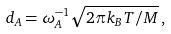<formula> <loc_0><loc_0><loc_500><loc_500>d _ { A } = \omega _ { A } ^ { - 1 } \sqrt { 2 \pi k _ { B } T / M } \, ,</formula> 